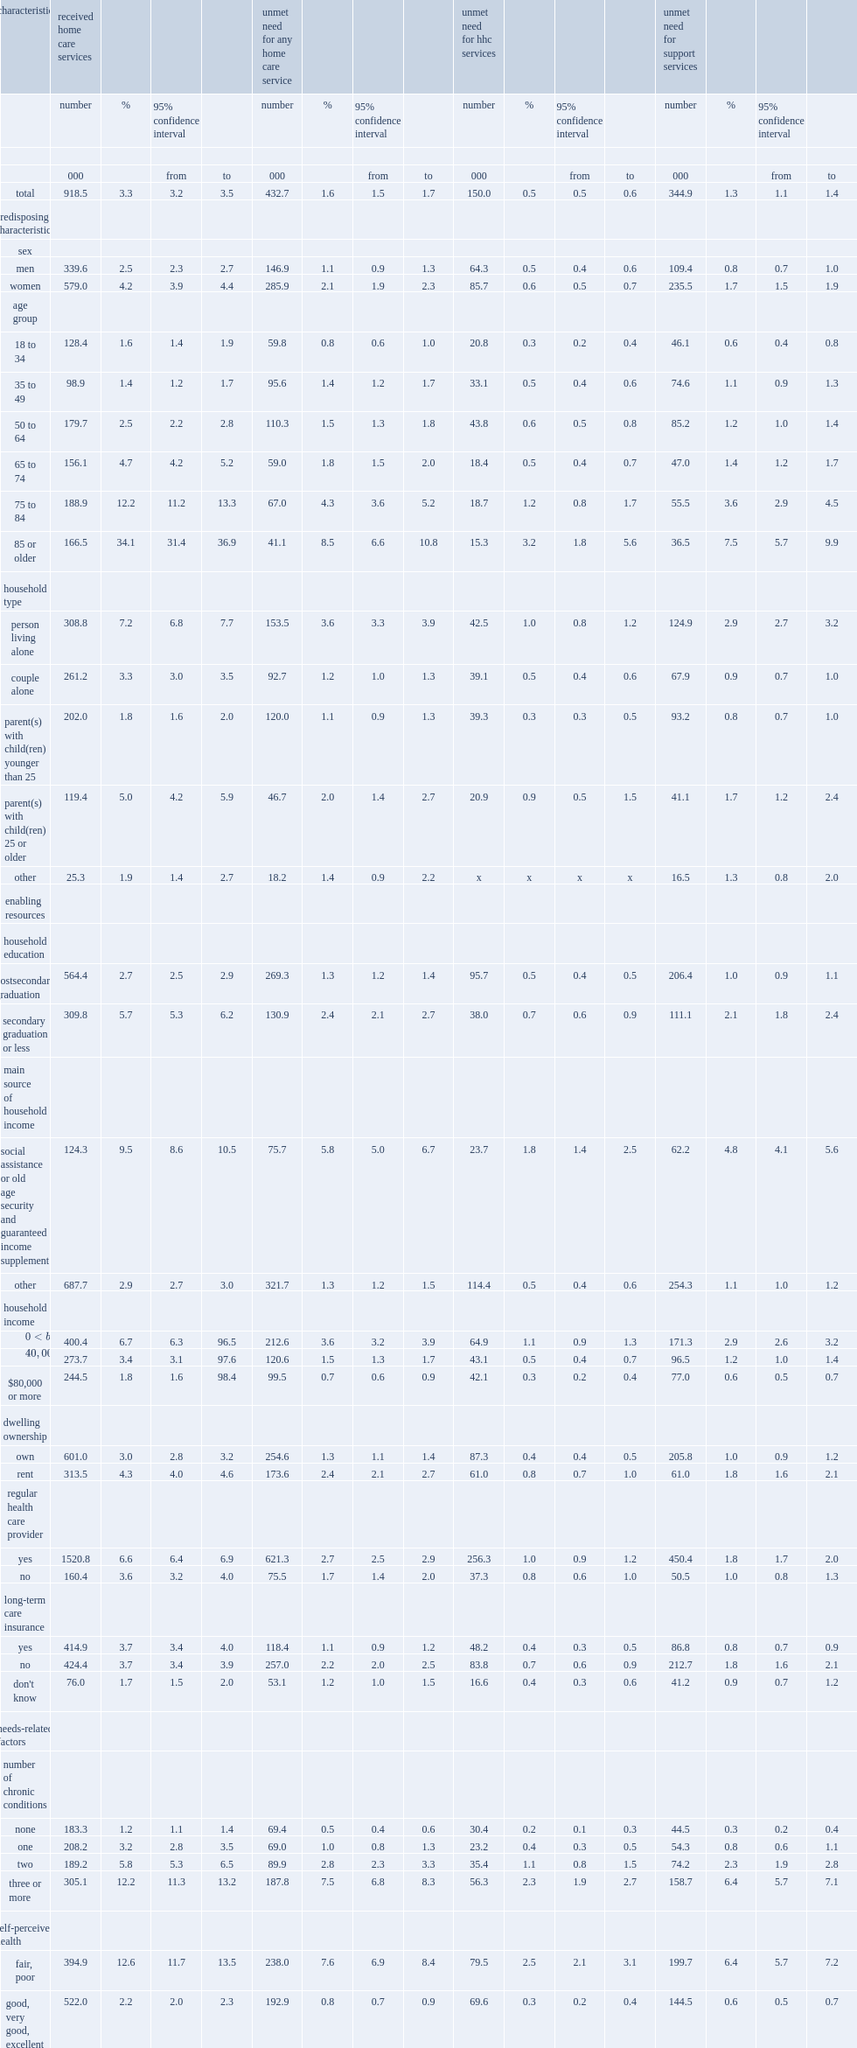In 2015/2016, what is the percentage of canadians aged 18 or older (919,000 people) had received home care services in the past year? 3.3. What is the percentage of a perceived unmet need for home care services of the adult population (433,000 people) in 2015/2016? 1.6. What is the percentage of unmet need for support services in 2015/2016? 1.3. What is the percentage of unmet need for hhc services in 2015/2016? 0.5. Compared with unmet need for support services and hhc services, which was more prevalent in 2015/2016? Unmet need for support services. Compared with women and men ,which gender was more likely than men to have an unmet support need in 2015/2016? Women. What is the percentage of women who have an unmet support need in 2015/2016? 1.7. What is the percentage of men who have an unmet support need in 2015/2016? 0.8. 